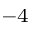Convert formula to latex. <formula><loc_0><loc_0><loc_500><loc_500>^ { 4 }</formula> 